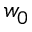<formula> <loc_0><loc_0><loc_500><loc_500>w _ { 0 }</formula> 